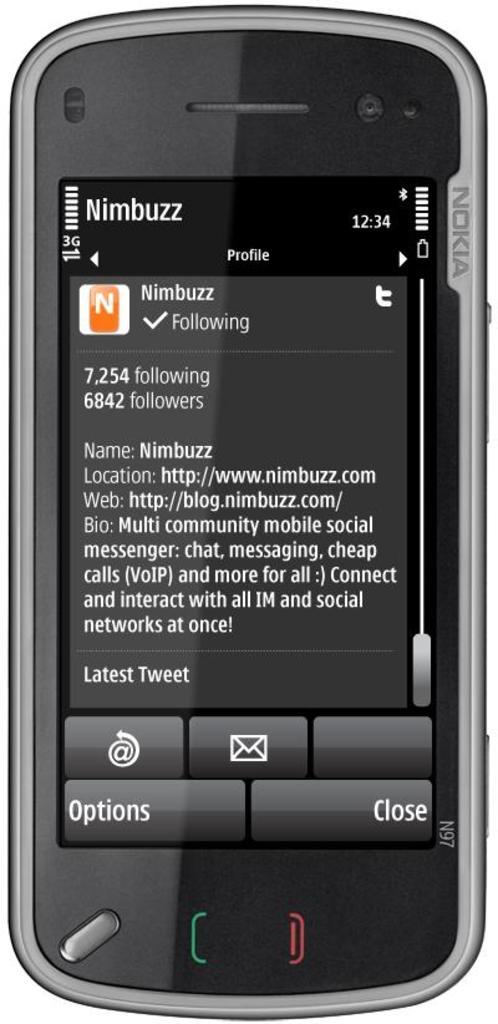<image>
Share a concise interpretation of the image provided. A phone showing a tweet from Nimbuzz on the screen. 